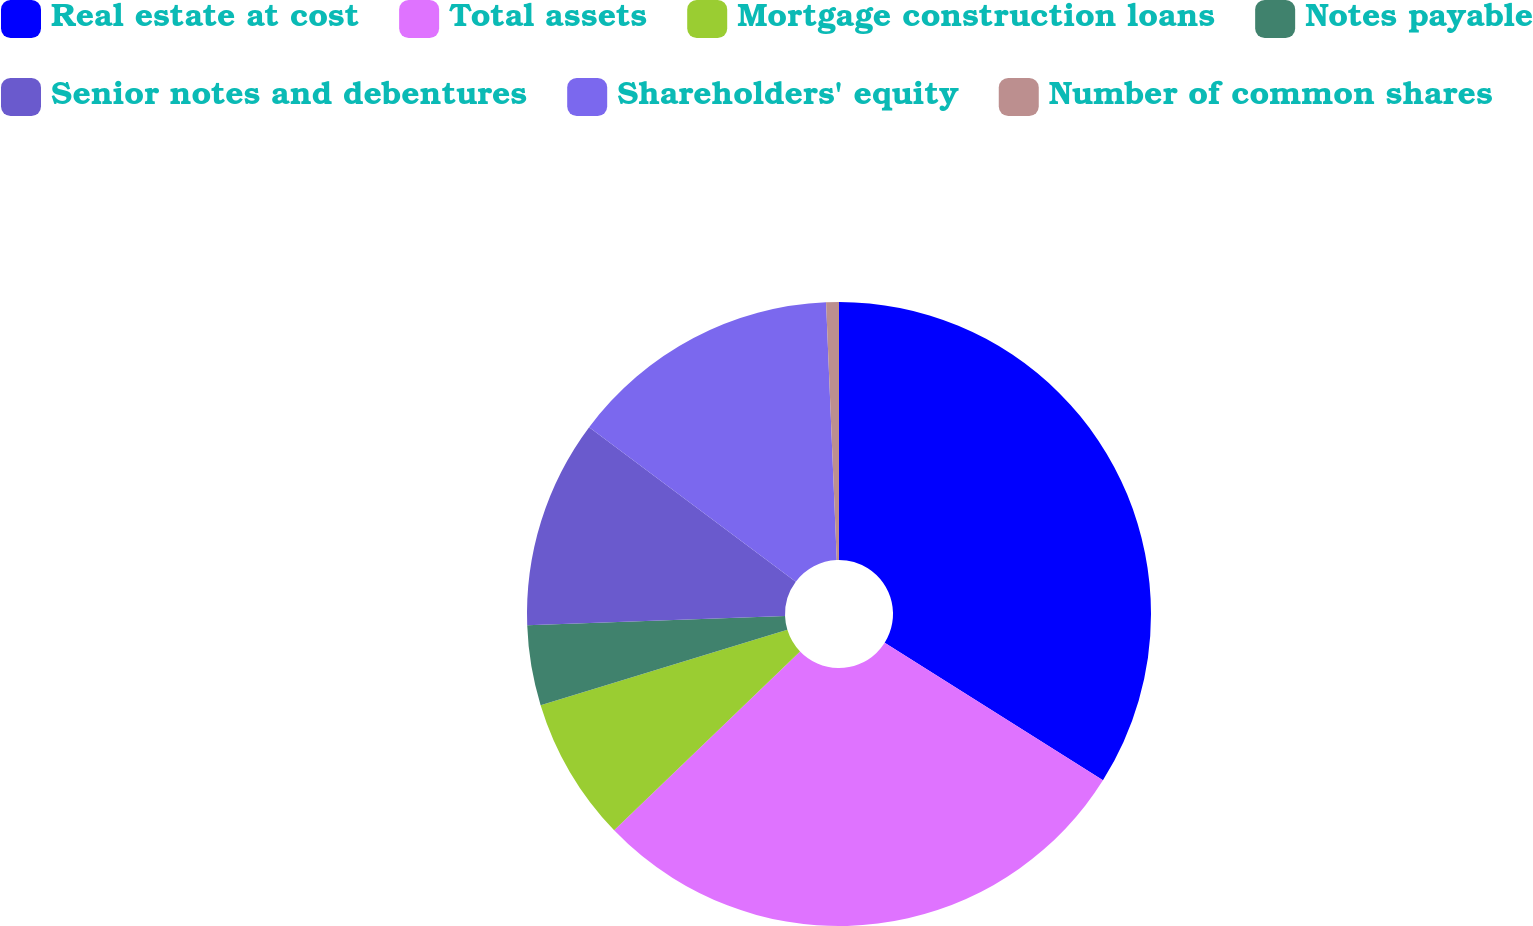Convert chart to OTSL. <chart><loc_0><loc_0><loc_500><loc_500><pie_chart><fcel>Real estate at cost<fcel>Total assets<fcel>Mortgage construction loans<fcel>Notes payable<fcel>Senior notes and debentures<fcel>Shareholders' equity<fcel>Number of common shares<nl><fcel>33.95%<fcel>28.86%<fcel>7.47%<fcel>4.14%<fcel>10.8%<fcel>14.12%<fcel>0.66%<nl></chart> 